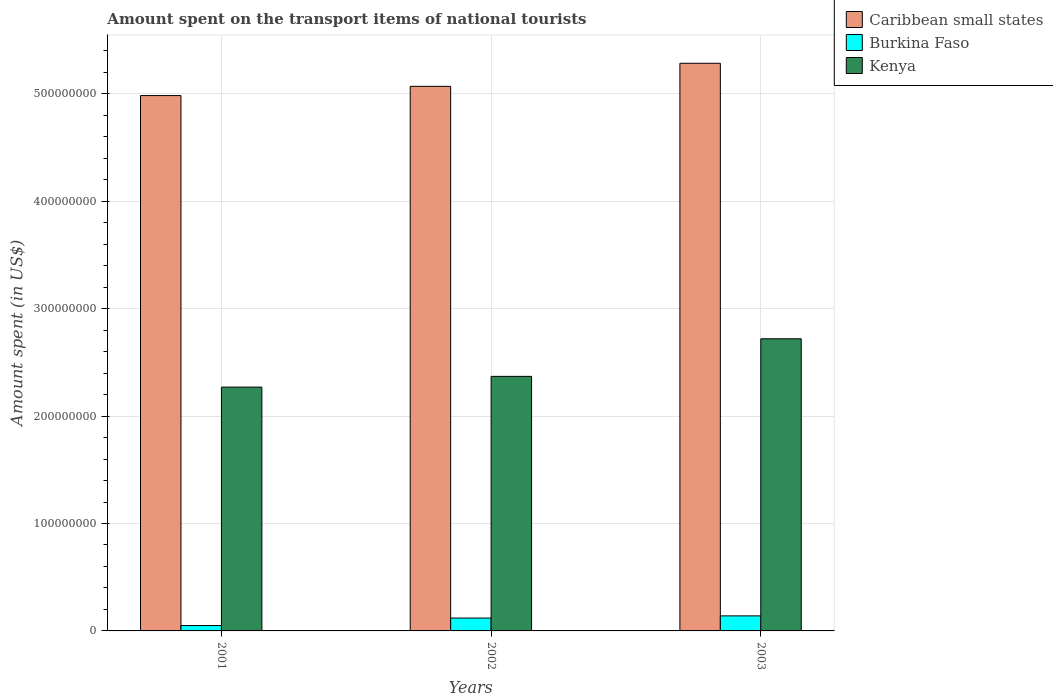Are the number of bars on each tick of the X-axis equal?
Provide a short and direct response. Yes. How many bars are there on the 3rd tick from the right?
Offer a terse response. 3. What is the label of the 3rd group of bars from the left?
Provide a succinct answer. 2003. In how many cases, is the number of bars for a given year not equal to the number of legend labels?
Offer a very short reply. 0. What is the amount spent on the transport items of national tourists in Kenya in 2001?
Ensure brevity in your answer.  2.27e+08. Across all years, what is the maximum amount spent on the transport items of national tourists in Kenya?
Provide a succinct answer. 2.72e+08. Across all years, what is the minimum amount spent on the transport items of national tourists in Kenya?
Make the answer very short. 2.27e+08. What is the total amount spent on the transport items of national tourists in Caribbean small states in the graph?
Your response must be concise. 1.53e+09. What is the difference between the amount spent on the transport items of national tourists in Caribbean small states in 2001 and that in 2002?
Give a very brief answer. -8.59e+06. What is the difference between the amount spent on the transport items of national tourists in Kenya in 2003 and the amount spent on the transport items of national tourists in Caribbean small states in 2002?
Ensure brevity in your answer.  -2.35e+08. What is the average amount spent on the transport items of national tourists in Caribbean small states per year?
Keep it short and to the point. 5.11e+08. In the year 2001, what is the difference between the amount spent on the transport items of national tourists in Caribbean small states and amount spent on the transport items of national tourists in Burkina Faso?
Ensure brevity in your answer.  4.93e+08. What is the ratio of the amount spent on the transport items of national tourists in Burkina Faso in 2001 to that in 2002?
Keep it short and to the point. 0.42. Is the amount spent on the transport items of national tourists in Burkina Faso in 2001 less than that in 2002?
Keep it short and to the point. Yes. What is the difference between the highest and the lowest amount spent on the transport items of national tourists in Kenya?
Your answer should be compact. 4.50e+07. Is the sum of the amount spent on the transport items of national tourists in Burkina Faso in 2002 and 2003 greater than the maximum amount spent on the transport items of national tourists in Kenya across all years?
Your answer should be compact. No. What does the 2nd bar from the left in 2001 represents?
Offer a terse response. Burkina Faso. What does the 2nd bar from the right in 2001 represents?
Give a very brief answer. Burkina Faso. How many bars are there?
Make the answer very short. 9. Are all the bars in the graph horizontal?
Make the answer very short. No. How many years are there in the graph?
Give a very brief answer. 3. What is the difference between two consecutive major ticks on the Y-axis?
Your answer should be compact. 1.00e+08. Are the values on the major ticks of Y-axis written in scientific E-notation?
Provide a succinct answer. No. How many legend labels are there?
Make the answer very short. 3. What is the title of the graph?
Provide a succinct answer. Amount spent on the transport items of national tourists. What is the label or title of the X-axis?
Keep it short and to the point. Years. What is the label or title of the Y-axis?
Ensure brevity in your answer.  Amount spent (in US$). What is the Amount spent (in US$) of Caribbean small states in 2001?
Offer a very short reply. 4.98e+08. What is the Amount spent (in US$) of Kenya in 2001?
Your response must be concise. 2.27e+08. What is the Amount spent (in US$) of Caribbean small states in 2002?
Make the answer very short. 5.07e+08. What is the Amount spent (in US$) in Kenya in 2002?
Keep it short and to the point. 2.37e+08. What is the Amount spent (in US$) in Caribbean small states in 2003?
Keep it short and to the point. 5.29e+08. What is the Amount spent (in US$) of Burkina Faso in 2003?
Provide a short and direct response. 1.40e+07. What is the Amount spent (in US$) in Kenya in 2003?
Provide a short and direct response. 2.72e+08. Across all years, what is the maximum Amount spent (in US$) in Caribbean small states?
Provide a short and direct response. 5.29e+08. Across all years, what is the maximum Amount spent (in US$) in Burkina Faso?
Offer a terse response. 1.40e+07. Across all years, what is the maximum Amount spent (in US$) in Kenya?
Provide a succinct answer. 2.72e+08. Across all years, what is the minimum Amount spent (in US$) of Caribbean small states?
Your response must be concise. 4.98e+08. Across all years, what is the minimum Amount spent (in US$) in Burkina Faso?
Provide a succinct answer. 5.00e+06. Across all years, what is the minimum Amount spent (in US$) of Kenya?
Keep it short and to the point. 2.27e+08. What is the total Amount spent (in US$) in Caribbean small states in the graph?
Your response must be concise. 1.53e+09. What is the total Amount spent (in US$) of Burkina Faso in the graph?
Offer a terse response. 3.10e+07. What is the total Amount spent (in US$) in Kenya in the graph?
Your response must be concise. 7.36e+08. What is the difference between the Amount spent (in US$) of Caribbean small states in 2001 and that in 2002?
Your answer should be compact. -8.59e+06. What is the difference between the Amount spent (in US$) in Burkina Faso in 2001 and that in 2002?
Your answer should be very brief. -7.00e+06. What is the difference between the Amount spent (in US$) of Kenya in 2001 and that in 2002?
Provide a short and direct response. -1.00e+07. What is the difference between the Amount spent (in US$) of Caribbean small states in 2001 and that in 2003?
Your answer should be very brief. -3.01e+07. What is the difference between the Amount spent (in US$) in Burkina Faso in 2001 and that in 2003?
Ensure brevity in your answer.  -9.00e+06. What is the difference between the Amount spent (in US$) of Kenya in 2001 and that in 2003?
Provide a short and direct response. -4.50e+07. What is the difference between the Amount spent (in US$) in Caribbean small states in 2002 and that in 2003?
Ensure brevity in your answer.  -2.15e+07. What is the difference between the Amount spent (in US$) in Burkina Faso in 2002 and that in 2003?
Provide a short and direct response. -2.00e+06. What is the difference between the Amount spent (in US$) of Kenya in 2002 and that in 2003?
Provide a succinct answer. -3.50e+07. What is the difference between the Amount spent (in US$) in Caribbean small states in 2001 and the Amount spent (in US$) in Burkina Faso in 2002?
Offer a terse response. 4.86e+08. What is the difference between the Amount spent (in US$) in Caribbean small states in 2001 and the Amount spent (in US$) in Kenya in 2002?
Your response must be concise. 2.61e+08. What is the difference between the Amount spent (in US$) of Burkina Faso in 2001 and the Amount spent (in US$) of Kenya in 2002?
Give a very brief answer. -2.32e+08. What is the difference between the Amount spent (in US$) in Caribbean small states in 2001 and the Amount spent (in US$) in Burkina Faso in 2003?
Give a very brief answer. 4.84e+08. What is the difference between the Amount spent (in US$) of Caribbean small states in 2001 and the Amount spent (in US$) of Kenya in 2003?
Make the answer very short. 2.26e+08. What is the difference between the Amount spent (in US$) in Burkina Faso in 2001 and the Amount spent (in US$) in Kenya in 2003?
Your answer should be compact. -2.67e+08. What is the difference between the Amount spent (in US$) of Caribbean small states in 2002 and the Amount spent (in US$) of Burkina Faso in 2003?
Your response must be concise. 4.93e+08. What is the difference between the Amount spent (in US$) of Caribbean small states in 2002 and the Amount spent (in US$) of Kenya in 2003?
Provide a short and direct response. 2.35e+08. What is the difference between the Amount spent (in US$) of Burkina Faso in 2002 and the Amount spent (in US$) of Kenya in 2003?
Make the answer very short. -2.60e+08. What is the average Amount spent (in US$) in Caribbean small states per year?
Your answer should be compact. 5.11e+08. What is the average Amount spent (in US$) in Burkina Faso per year?
Your response must be concise. 1.03e+07. What is the average Amount spent (in US$) of Kenya per year?
Offer a terse response. 2.45e+08. In the year 2001, what is the difference between the Amount spent (in US$) in Caribbean small states and Amount spent (in US$) in Burkina Faso?
Give a very brief answer. 4.93e+08. In the year 2001, what is the difference between the Amount spent (in US$) of Caribbean small states and Amount spent (in US$) of Kenya?
Ensure brevity in your answer.  2.71e+08. In the year 2001, what is the difference between the Amount spent (in US$) in Burkina Faso and Amount spent (in US$) in Kenya?
Your answer should be compact. -2.22e+08. In the year 2002, what is the difference between the Amount spent (in US$) in Caribbean small states and Amount spent (in US$) in Burkina Faso?
Ensure brevity in your answer.  4.95e+08. In the year 2002, what is the difference between the Amount spent (in US$) in Caribbean small states and Amount spent (in US$) in Kenya?
Your answer should be compact. 2.70e+08. In the year 2002, what is the difference between the Amount spent (in US$) of Burkina Faso and Amount spent (in US$) of Kenya?
Offer a terse response. -2.25e+08. In the year 2003, what is the difference between the Amount spent (in US$) of Caribbean small states and Amount spent (in US$) of Burkina Faso?
Make the answer very short. 5.15e+08. In the year 2003, what is the difference between the Amount spent (in US$) of Caribbean small states and Amount spent (in US$) of Kenya?
Your response must be concise. 2.57e+08. In the year 2003, what is the difference between the Amount spent (in US$) in Burkina Faso and Amount spent (in US$) in Kenya?
Provide a short and direct response. -2.58e+08. What is the ratio of the Amount spent (in US$) in Caribbean small states in 2001 to that in 2002?
Offer a very short reply. 0.98. What is the ratio of the Amount spent (in US$) in Burkina Faso in 2001 to that in 2002?
Keep it short and to the point. 0.42. What is the ratio of the Amount spent (in US$) in Kenya in 2001 to that in 2002?
Give a very brief answer. 0.96. What is the ratio of the Amount spent (in US$) of Caribbean small states in 2001 to that in 2003?
Ensure brevity in your answer.  0.94. What is the ratio of the Amount spent (in US$) in Burkina Faso in 2001 to that in 2003?
Your answer should be compact. 0.36. What is the ratio of the Amount spent (in US$) of Kenya in 2001 to that in 2003?
Keep it short and to the point. 0.83. What is the ratio of the Amount spent (in US$) of Caribbean small states in 2002 to that in 2003?
Your answer should be very brief. 0.96. What is the ratio of the Amount spent (in US$) in Burkina Faso in 2002 to that in 2003?
Provide a short and direct response. 0.86. What is the ratio of the Amount spent (in US$) of Kenya in 2002 to that in 2003?
Ensure brevity in your answer.  0.87. What is the difference between the highest and the second highest Amount spent (in US$) of Caribbean small states?
Provide a short and direct response. 2.15e+07. What is the difference between the highest and the second highest Amount spent (in US$) in Burkina Faso?
Provide a short and direct response. 2.00e+06. What is the difference between the highest and the second highest Amount spent (in US$) of Kenya?
Give a very brief answer. 3.50e+07. What is the difference between the highest and the lowest Amount spent (in US$) of Caribbean small states?
Ensure brevity in your answer.  3.01e+07. What is the difference between the highest and the lowest Amount spent (in US$) of Burkina Faso?
Provide a succinct answer. 9.00e+06. What is the difference between the highest and the lowest Amount spent (in US$) of Kenya?
Keep it short and to the point. 4.50e+07. 